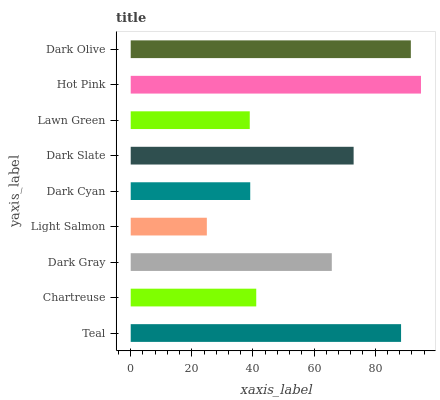Is Light Salmon the minimum?
Answer yes or no. Yes. Is Hot Pink the maximum?
Answer yes or no. Yes. Is Chartreuse the minimum?
Answer yes or no. No. Is Chartreuse the maximum?
Answer yes or no. No. Is Teal greater than Chartreuse?
Answer yes or no. Yes. Is Chartreuse less than Teal?
Answer yes or no. Yes. Is Chartreuse greater than Teal?
Answer yes or no. No. Is Teal less than Chartreuse?
Answer yes or no. No. Is Dark Gray the high median?
Answer yes or no. Yes. Is Dark Gray the low median?
Answer yes or no. Yes. Is Lawn Green the high median?
Answer yes or no. No. Is Chartreuse the low median?
Answer yes or no. No. 